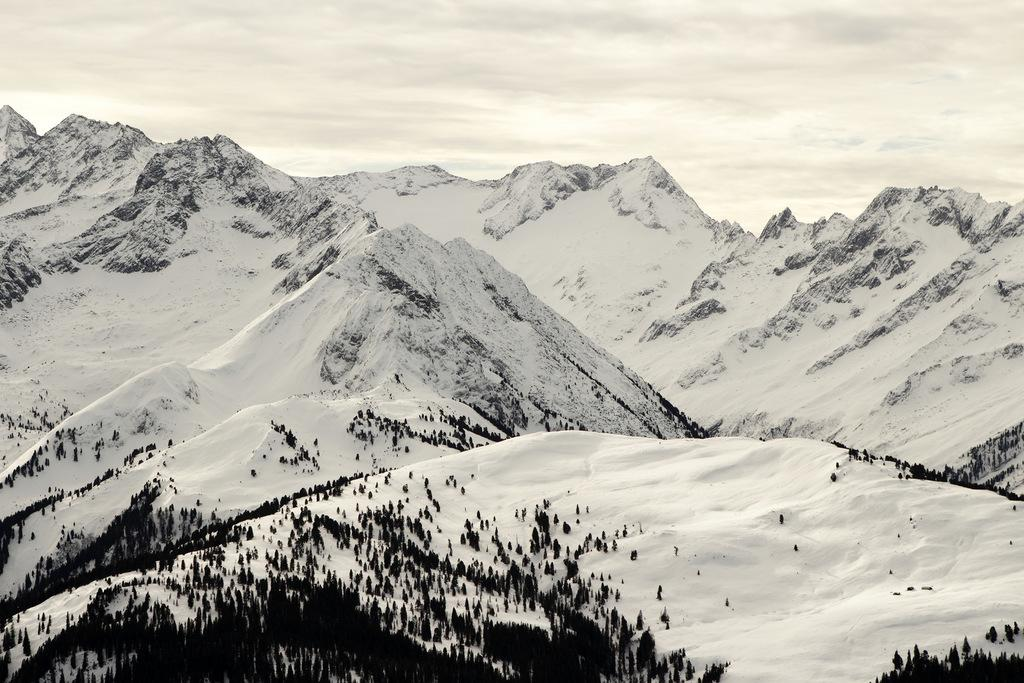What type of natural formation can be seen in the image? There are mountains in the image. What is visible in the background of the image? The sky is visible in the background of the image. What type of vegetation is present at the bottom of the image? There are trees at the bottom of the image. What type of weather condition is depicted in the image? There is snow at the bottom of the image, indicating a cold or snowy weather condition. What type of steel structure can be seen in the image? There is no steel structure present in the image; it features mountains, sky, trees, and snow. What impulse might have caused the mountains to form in the image? The formation of mountains is a natural geological process that occurs over millions of years, and it is not caused by any specific impulse. 